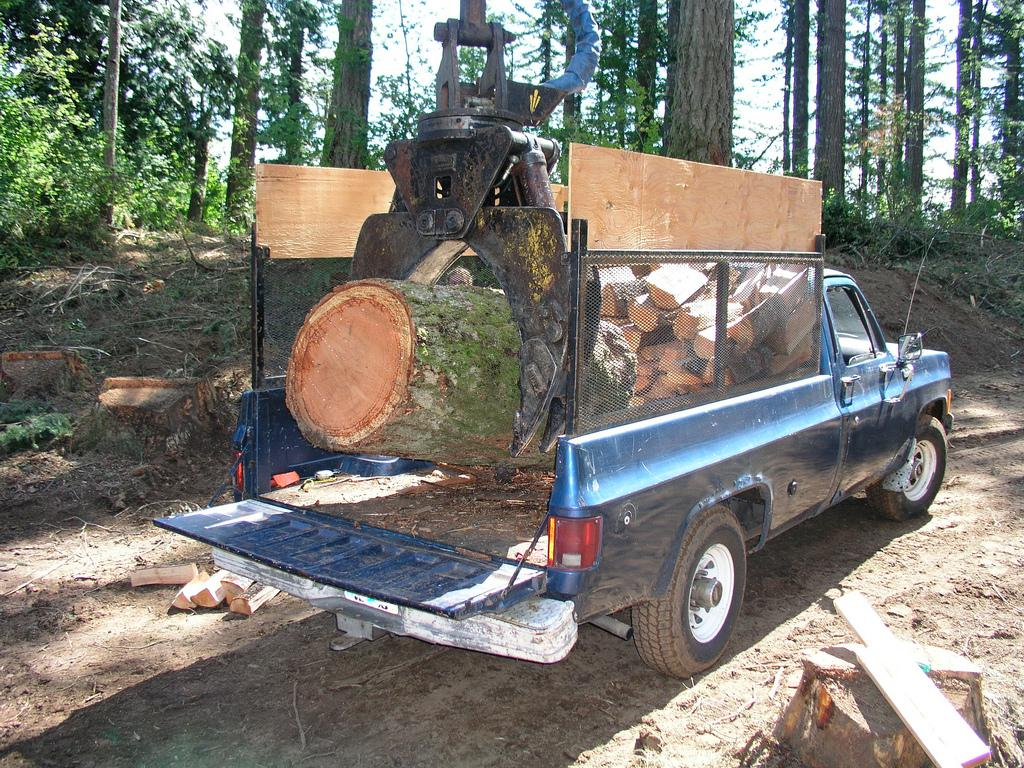Question: what is in the bed of the truck?
Choices:
A. Bed liner.
B. Camping gear.
C. Wood.
D. Ice box.
Answer with the letter. Answer: C Question: how is the wood being loaded into the truck?
Choices:
A. By the workers.
B. By the employees.
C. By hand.
D. Using a grapple.
Answer with the letter. Answer: D Question: what color is the truck?
Choices:
A. Two shades of blue.
B. Black.
C. Orange.
D. Brown.
Answer with the letter. Answer: A Question: why is the tail gate down?
Choices:
A. To make it easier to load.
B. To sit on.
C. To place tools.
D. To place food on.
Answer with the letter. Answer: A Question: what color is the truck?
Choices:
A. Blue.
B. Red.
C. Green.
D. Black.
Answer with the letter. Answer: A Question: what is on the log in the truck?
Choices:
A. A squirrel.
B. Moss.
C. Tree leaves.
D. Rope.
Answer with the letter. Answer: B Question: what has been used to extend the truck's side?
Choices:
A. Metal.
B. Planks.
C. Plywood.
D. Plastic.
Answer with the letter. Answer: C Question: what is laying on the ground near the pickup truck?
Choices:
A. Several large sticks.
B. Lots of branches.
C. Some small logs.
D. Several stumps.
Answer with the letter. Answer: C Question: where are there several small cut logs?
Choices:
A. Sitting beside the car.
B. Standing up next to the bike.
C. Stacked behind the bus.
D. Laying next to the truck.
Answer with the letter. Answer: D Question: what is dirty?
Choices:
A. Truck tires.
B. The toilet.
C. Work boots.
D. The old car.
Answer with the letter. Answer: A Question: what is the weather like?
Choices:
A. Rainy.
B. Sunny.
C. Hurricane.
D. Tornado warning.
Answer with the letter. Answer: B Question: what direction do the tires face?
Choices:
A. Left.
B. Straight ahead.
C. Toward the curb.
D. Right.
Answer with the letter. Answer: D Question: what is the color of the wheel's hubs?
Choices:
A. Black.
B. Silver.
C. Gold.
D. White.
Answer with the letter. Answer: D Question: where can you see the truck's shadow?
Choices:
A. On the street.
B. Underneath and behind it.
C. On the building.
D. In front of it.
Answer with the letter. Answer: B Question: what is strewn with debris?
Choices:
A. The street.
B. My backyard.
C. The town after a tornado.
D. Bed of pickup.
Answer with the letter. Answer: D 